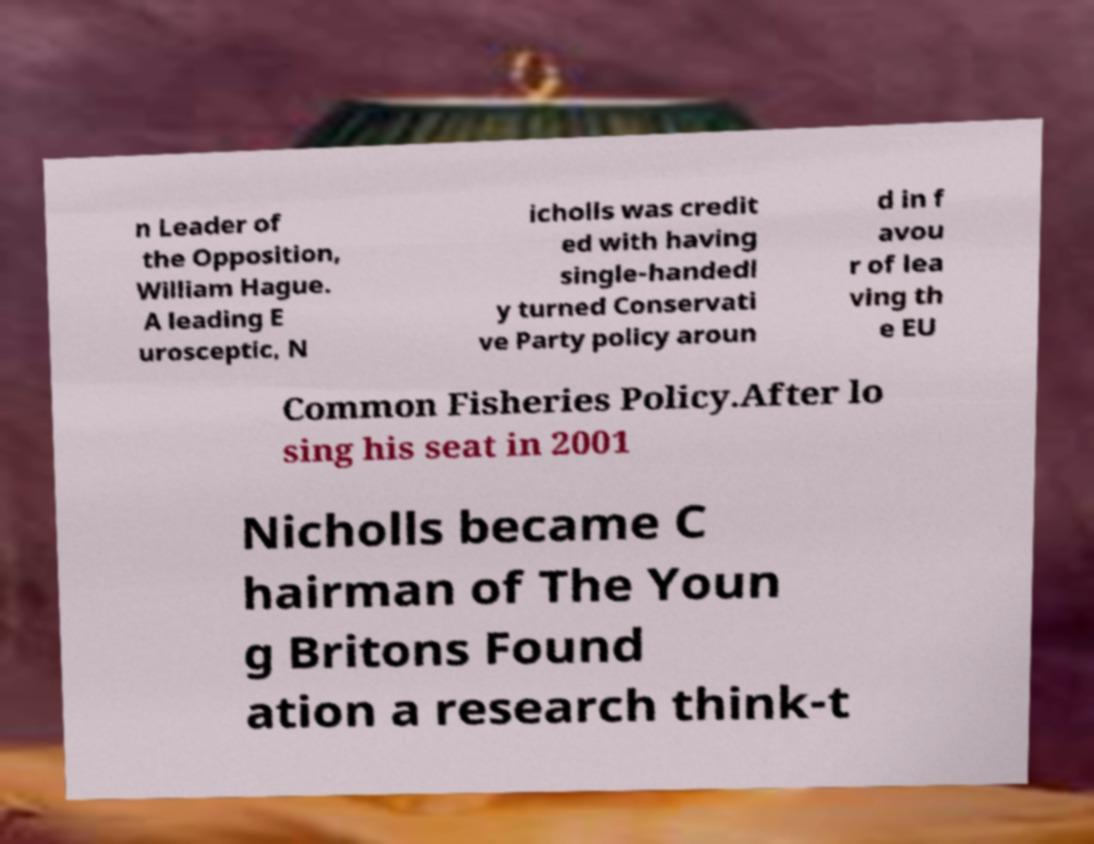I need the written content from this picture converted into text. Can you do that? n Leader of the Opposition, William Hague. A leading E urosceptic, N icholls was credit ed with having single-handedl y turned Conservati ve Party policy aroun d in f avou r of lea ving th e EU Common Fisheries Policy.After lo sing his seat in 2001 Nicholls became C hairman of The Youn g Britons Found ation a research think-t 